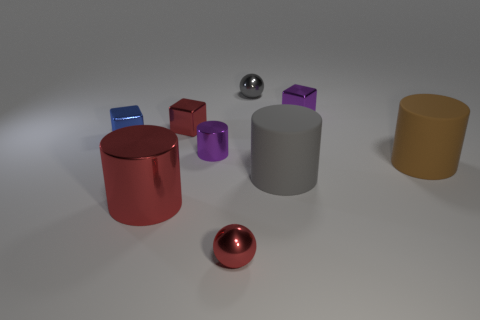What color is the tiny metallic ball to the left of the gray metallic ball right of the small red sphere?
Ensure brevity in your answer.  Red. What material is the large gray object that is the same shape as the big brown thing?
Offer a terse response. Rubber. How many shiny objects are tiny gray objects or big gray cylinders?
Provide a succinct answer. 1. Does the small blue cube that is in front of the small gray ball have the same material as the red thing behind the big gray cylinder?
Provide a succinct answer. Yes. Are any green matte cylinders visible?
Offer a very short reply. No. Do the red object behind the large brown thing and the gray thing that is in front of the purple cylinder have the same shape?
Ensure brevity in your answer.  No. Are there any large red cylinders made of the same material as the brown cylinder?
Provide a succinct answer. No. Is the material of the blue object on the left side of the gray rubber object the same as the small red cube?
Your response must be concise. Yes. Is the number of tiny red cubes that are on the right side of the tiny red shiny sphere greater than the number of metal cylinders that are on the right side of the small purple shiny cylinder?
Your response must be concise. No. The other rubber cylinder that is the same size as the brown cylinder is what color?
Provide a short and direct response. Gray. 